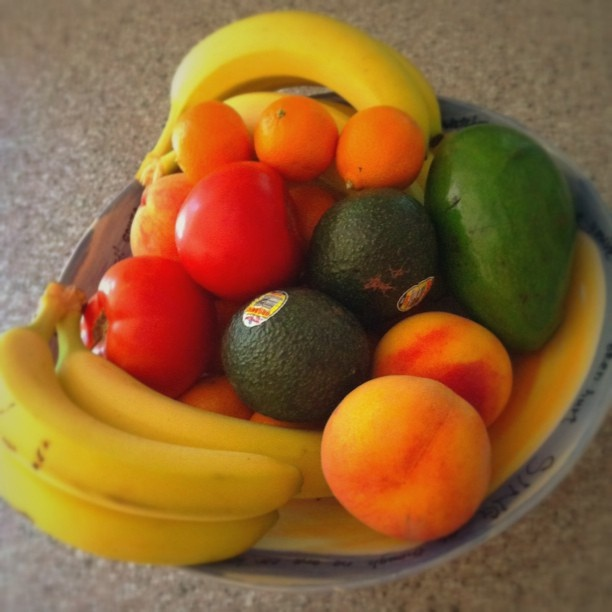Describe the objects in this image and their specific colors. I can see bowl in gray, black, olive, red, and orange tones, banana in gray, orange, olive, and maroon tones, banana in gray, orange, khaki, and olive tones, orange in gray, red, brown, and maroon tones, and orange in gray, red, brown, and orange tones in this image. 